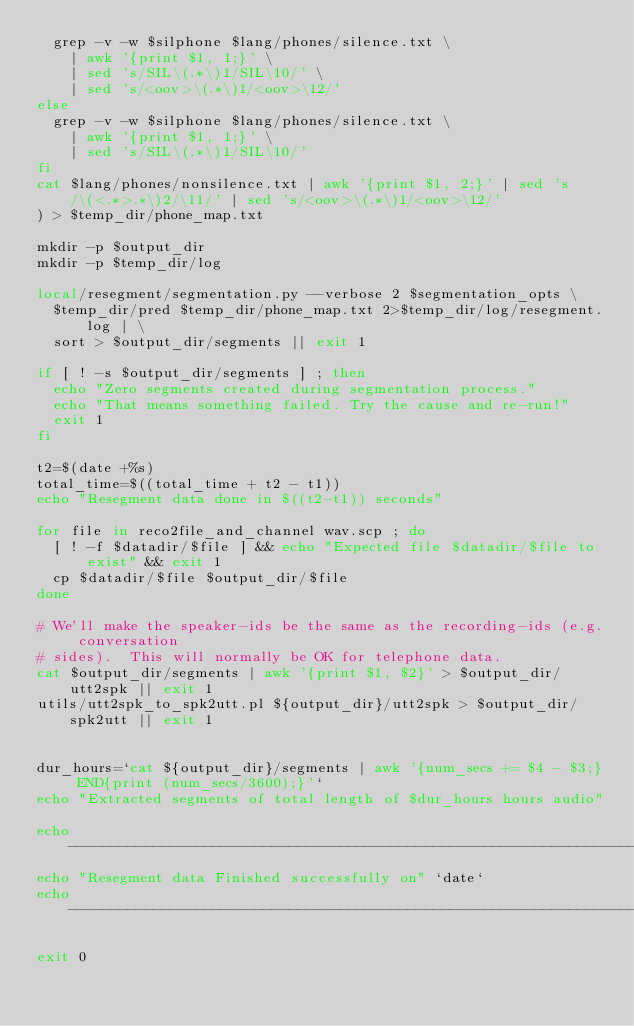Convert code to text. <code><loc_0><loc_0><loc_500><loc_500><_Bash_>  grep -v -w $silphone $lang/phones/silence.txt \
    | awk '{print $1, 1;}' \
    | sed 's/SIL\(.*\)1/SIL\10/' \
    | sed 's/<oov>\(.*\)1/<oov>\12/'
else
  grep -v -w $silphone $lang/phones/silence.txt \
    | awk '{print $1, 1;}' \
    | sed 's/SIL\(.*\)1/SIL\10/'
fi
cat $lang/phones/nonsilence.txt | awk '{print $1, 2;}' | sed 's/\(<.*>.*\)2/\11/' | sed 's/<oov>\(.*\)1/<oov>\12/'
) > $temp_dir/phone_map.txt

mkdir -p $output_dir
mkdir -p $temp_dir/log

local/resegment/segmentation.py --verbose 2 $segmentation_opts \
  $temp_dir/pred $temp_dir/phone_map.txt 2>$temp_dir/log/resegment.log | \
  sort > $output_dir/segments || exit 1

if [ ! -s $output_dir/segments ] ; then
  echo "Zero segments created during segmentation process."
  echo "That means something failed. Try the cause and re-run!"
  exit 1
fi

t2=$(date +%s)
total_time=$((total_time + t2 - t1))
echo "Resegment data done in $((t2-t1)) seconds"

for file in reco2file_and_channel wav.scp ; do
  [ ! -f $datadir/$file ] && echo "Expected file $datadir/$file to exist" && exit 1
  cp $datadir/$file $output_dir/$file
done

# We'll make the speaker-ids be the same as the recording-ids (e.g. conversation
# sides).  This will normally be OK for telephone data.
cat $output_dir/segments | awk '{print $1, $2}' > $output_dir/utt2spk || exit 1
utils/utt2spk_to_spk2utt.pl ${output_dir}/utt2spk > $output_dir/spk2utt || exit 1


dur_hours=`cat ${output_dir}/segments | awk '{num_secs += $4 - $3;} END{print (num_secs/3600);}'`
echo "Extracted segments of total length of $dur_hours hours audio"

echo ---------------------------------------------------------------------
echo "Resegment data Finished successfully on" `date`
echo ---------------------------------------------------------------------

exit 0
</code> 